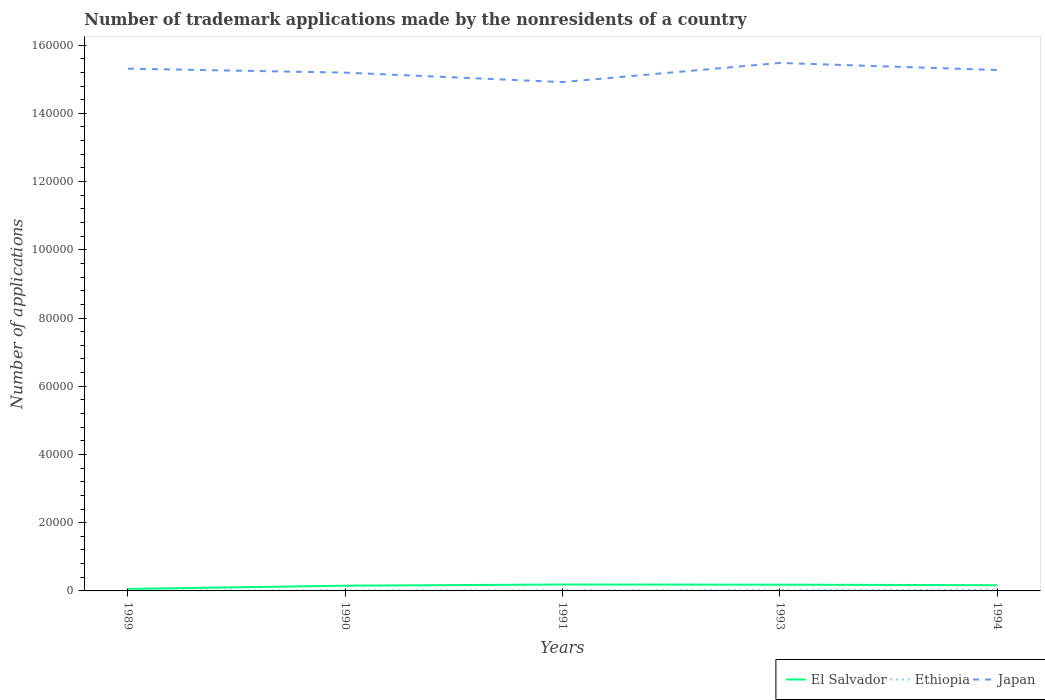How many different coloured lines are there?
Your response must be concise. 3. Across all years, what is the maximum number of trademark applications made by the nonresidents in Japan?
Make the answer very short. 1.49e+05. In which year was the number of trademark applications made by the nonresidents in Japan maximum?
Offer a very short reply. 1991. What is the total number of trademark applications made by the nonresidents in Japan in the graph?
Your answer should be very brief. -2839. What is the difference between the highest and the second highest number of trademark applications made by the nonresidents in Ethiopia?
Offer a terse response. 217. How many lines are there?
Provide a short and direct response. 3. Are the values on the major ticks of Y-axis written in scientific E-notation?
Offer a very short reply. No. How many legend labels are there?
Ensure brevity in your answer.  3. How are the legend labels stacked?
Provide a succinct answer. Horizontal. What is the title of the graph?
Ensure brevity in your answer.  Number of trademark applications made by the nonresidents of a country. What is the label or title of the Y-axis?
Give a very brief answer. Number of applications. What is the Number of applications of El Salvador in 1989?
Offer a very short reply. 581. What is the Number of applications in Ethiopia in 1989?
Provide a short and direct response. 128. What is the Number of applications of Japan in 1989?
Your answer should be very brief. 1.53e+05. What is the Number of applications in El Salvador in 1990?
Give a very brief answer. 1535. What is the Number of applications in Ethiopia in 1990?
Make the answer very short. 177. What is the Number of applications of Japan in 1990?
Ensure brevity in your answer.  1.52e+05. What is the Number of applications in El Salvador in 1991?
Provide a succinct answer. 1883. What is the Number of applications of Ethiopia in 1991?
Ensure brevity in your answer.  156. What is the Number of applications in Japan in 1991?
Keep it short and to the point. 1.49e+05. What is the Number of applications in El Salvador in 1993?
Make the answer very short. 1834. What is the Number of applications in Ethiopia in 1993?
Your answer should be compact. 235. What is the Number of applications in Japan in 1993?
Provide a succinct answer. 1.55e+05. What is the Number of applications in El Salvador in 1994?
Offer a very short reply. 1681. What is the Number of applications in Ethiopia in 1994?
Keep it short and to the point. 345. What is the Number of applications of Japan in 1994?
Offer a terse response. 1.53e+05. Across all years, what is the maximum Number of applications in El Salvador?
Ensure brevity in your answer.  1883. Across all years, what is the maximum Number of applications of Ethiopia?
Keep it short and to the point. 345. Across all years, what is the maximum Number of applications in Japan?
Make the answer very short. 1.55e+05. Across all years, what is the minimum Number of applications in El Salvador?
Your response must be concise. 581. Across all years, what is the minimum Number of applications in Ethiopia?
Keep it short and to the point. 128. Across all years, what is the minimum Number of applications in Japan?
Your answer should be very brief. 1.49e+05. What is the total Number of applications of El Salvador in the graph?
Your answer should be very brief. 7514. What is the total Number of applications in Ethiopia in the graph?
Offer a very short reply. 1041. What is the total Number of applications of Japan in the graph?
Your answer should be very brief. 7.62e+05. What is the difference between the Number of applications of El Salvador in 1989 and that in 1990?
Provide a short and direct response. -954. What is the difference between the Number of applications of Ethiopia in 1989 and that in 1990?
Your answer should be compact. -49. What is the difference between the Number of applications in Japan in 1989 and that in 1990?
Give a very brief answer. 1166. What is the difference between the Number of applications of El Salvador in 1989 and that in 1991?
Your answer should be very brief. -1302. What is the difference between the Number of applications of Japan in 1989 and that in 1991?
Your response must be concise. 3938. What is the difference between the Number of applications of El Salvador in 1989 and that in 1993?
Make the answer very short. -1253. What is the difference between the Number of applications in Ethiopia in 1989 and that in 1993?
Offer a very short reply. -107. What is the difference between the Number of applications in Japan in 1989 and that in 1993?
Give a very brief answer. -1673. What is the difference between the Number of applications in El Salvador in 1989 and that in 1994?
Your response must be concise. -1100. What is the difference between the Number of applications of Ethiopia in 1989 and that in 1994?
Ensure brevity in your answer.  -217. What is the difference between the Number of applications of Japan in 1989 and that in 1994?
Your response must be concise. 393. What is the difference between the Number of applications of El Salvador in 1990 and that in 1991?
Give a very brief answer. -348. What is the difference between the Number of applications in Ethiopia in 1990 and that in 1991?
Make the answer very short. 21. What is the difference between the Number of applications in Japan in 1990 and that in 1991?
Keep it short and to the point. 2772. What is the difference between the Number of applications of El Salvador in 1990 and that in 1993?
Provide a short and direct response. -299. What is the difference between the Number of applications in Ethiopia in 1990 and that in 1993?
Offer a very short reply. -58. What is the difference between the Number of applications of Japan in 1990 and that in 1993?
Offer a terse response. -2839. What is the difference between the Number of applications of El Salvador in 1990 and that in 1994?
Keep it short and to the point. -146. What is the difference between the Number of applications in Ethiopia in 1990 and that in 1994?
Provide a succinct answer. -168. What is the difference between the Number of applications of Japan in 1990 and that in 1994?
Your answer should be very brief. -773. What is the difference between the Number of applications of Ethiopia in 1991 and that in 1993?
Give a very brief answer. -79. What is the difference between the Number of applications of Japan in 1991 and that in 1993?
Your response must be concise. -5611. What is the difference between the Number of applications of El Salvador in 1991 and that in 1994?
Offer a terse response. 202. What is the difference between the Number of applications of Ethiopia in 1991 and that in 1994?
Provide a succinct answer. -189. What is the difference between the Number of applications in Japan in 1991 and that in 1994?
Ensure brevity in your answer.  -3545. What is the difference between the Number of applications in El Salvador in 1993 and that in 1994?
Offer a terse response. 153. What is the difference between the Number of applications of Ethiopia in 1993 and that in 1994?
Ensure brevity in your answer.  -110. What is the difference between the Number of applications of Japan in 1993 and that in 1994?
Provide a short and direct response. 2066. What is the difference between the Number of applications of El Salvador in 1989 and the Number of applications of Ethiopia in 1990?
Offer a very short reply. 404. What is the difference between the Number of applications in El Salvador in 1989 and the Number of applications in Japan in 1990?
Provide a short and direct response. -1.51e+05. What is the difference between the Number of applications in Ethiopia in 1989 and the Number of applications in Japan in 1990?
Give a very brief answer. -1.52e+05. What is the difference between the Number of applications of El Salvador in 1989 and the Number of applications of Ethiopia in 1991?
Make the answer very short. 425. What is the difference between the Number of applications of El Salvador in 1989 and the Number of applications of Japan in 1991?
Provide a succinct answer. -1.49e+05. What is the difference between the Number of applications in Ethiopia in 1989 and the Number of applications in Japan in 1991?
Offer a very short reply. -1.49e+05. What is the difference between the Number of applications in El Salvador in 1989 and the Number of applications in Ethiopia in 1993?
Your response must be concise. 346. What is the difference between the Number of applications in El Salvador in 1989 and the Number of applications in Japan in 1993?
Provide a short and direct response. -1.54e+05. What is the difference between the Number of applications of Ethiopia in 1989 and the Number of applications of Japan in 1993?
Your response must be concise. -1.55e+05. What is the difference between the Number of applications of El Salvador in 1989 and the Number of applications of Ethiopia in 1994?
Your answer should be very brief. 236. What is the difference between the Number of applications in El Salvador in 1989 and the Number of applications in Japan in 1994?
Make the answer very short. -1.52e+05. What is the difference between the Number of applications in Ethiopia in 1989 and the Number of applications in Japan in 1994?
Your answer should be very brief. -1.53e+05. What is the difference between the Number of applications of El Salvador in 1990 and the Number of applications of Ethiopia in 1991?
Give a very brief answer. 1379. What is the difference between the Number of applications of El Salvador in 1990 and the Number of applications of Japan in 1991?
Make the answer very short. -1.48e+05. What is the difference between the Number of applications of Ethiopia in 1990 and the Number of applications of Japan in 1991?
Provide a succinct answer. -1.49e+05. What is the difference between the Number of applications of El Salvador in 1990 and the Number of applications of Ethiopia in 1993?
Your answer should be very brief. 1300. What is the difference between the Number of applications of El Salvador in 1990 and the Number of applications of Japan in 1993?
Provide a succinct answer. -1.53e+05. What is the difference between the Number of applications in Ethiopia in 1990 and the Number of applications in Japan in 1993?
Offer a terse response. -1.55e+05. What is the difference between the Number of applications of El Salvador in 1990 and the Number of applications of Ethiopia in 1994?
Offer a terse response. 1190. What is the difference between the Number of applications of El Salvador in 1990 and the Number of applications of Japan in 1994?
Provide a short and direct response. -1.51e+05. What is the difference between the Number of applications in Ethiopia in 1990 and the Number of applications in Japan in 1994?
Your answer should be compact. -1.53e+05. What is the difference between the Number of applications of El Salvador in 1991 and the Number of applications of Ethiopia in 1993?
Your response must be concise. 1648. What is the difference between the Number of applications of El Salvador in 1991 and the Number of applications of Japan in 1993?
Offer a terse response. -1.53e+05. What is the difference between the Number of applications of Ethiopia in 1991 and the Number of applications of Japan in 1993?
Your response must be concise. -1.55e+05. What is the difference between the Number of applications of El Salvador in 1991 and the Number of applications of Ethiopia in 1994?
Your response must be concise. 1538. What is the difference between the Number of applications in El Salvador in 1991 and the Number of applications in Japan in 1994?
Give a very brief answer. -1.51e+05. What is the difference between the Number of applications in Ethiopia in 1991 and the Number of applications in Japan in 1994?
Ensure brevity in your answer.  -1.53e+05. What is the difference between the Number of applications of El Salvador in 1993 and the Number of applications of Ethiopia in 1994?
Keep it short and to the point. 1489. What is the difference between the Number of applications in El Salvador in 1993 and the Number of applications in Japan in 1994?
Offer a terse response. -1.51e+05. What is the difference between the Number of applications of Ethiopia in 1993 and the Number of applications of Japan in 1994?
Your response must be concise. -1.52e+05. What is the average Number of applications in El Salvador per year?
Provide a short and direct response. 1502.8. What is the average Number of applications of Ethiopia per year?
Make the answer very short. 208.2. What is the average Number of applications in Japan per year?
Your answer should be very brief. 1.52e+05. In the year 1989, what is the difference between the Number of applications of El Salvador and Number of applications of Ethiopia?
Ensure brevity in your answer.  453. In the year 1989, what is the difference between the Number of applications in El Salvador and Number of applications in Japan?
Provide a succinct answer. -1.53e+05. In the year 1989, what is the difference between the Number of applications in Ethiopia and Number of applications in Japan?
Offer a terse response. -1.53e+05. In the year 1990, what is the difference between the Number of applications of El Salvador and Number of applications of Ethiopia?
Your response must be concise. 1358. In the year 1990, what is the difference between the Number of applications of El Salvador and Number of applications of Japan?
Keep it short and to the point. -1.50e+05. In the year 1990, what is the difference between the Number of applications of Ethiopia and Number of applications of Japan?
Offer a very short reply. -1.52e+05. In the year 1991, what is the difference between the Number of applications in El Salvador and Number of applications in Ethiopia?
Provide a succinct answer. 1727. In the year 1991, what is the difference between the Number of applications of El Salvador and Number of applications of Japan?
Provide a short and direct response. -1.47e+05. In the year 1991, what is the difference between the Number of applications of Ethiopia and Number of applications of Japan?
Your response must be concise. -1.49e+05. In the year 1993, what is the difference between the Number of applications of El Salvador and Number of applications of Ethiopia?
Offer a very short reply. 1599. In the year 1993, what is the difference between the Number of applications of El Salvador and Number of applications of Japan?
Give a very brief answer. -1.53e+05. In the year 1993, what is the difference between the Number of applications of Ethiopia and Number of applications of Japan?
Offer a very short reply. -1.55e+05. In the year 1994, what is the difference between the Number of applications of El Salvador and Number of applications of Ethiopia?
Your answer should be very brief. 1336. In the year 1994, what is the difference between the Number of applications of El Salvador and Number of applications of Japan?
Give a very brief answer. -1.51e+05. In the year 1994, what is the difference between the Number of applications in Ethiopia and Number of applications in Japan?
Your answer should be very brief. -1.52e+05. What is the ratio of the Number of applications of El Salvador in 1989 to that in 1990?
Offer a terse response. 0.38. What is the ratio of the Number of applications in Ethiopia in 1989 to that in 1990?
Offer a terse response. 0.72. What is the ratio of the Number of applications in Japan in 1989 to that in 1990?
Your answer should be compact. 1.01. What is the ratio of the Number of applications of El Salvador in 1989 to that in 1991?
Keep it short and to the point. 0.31. What is the ratio of the Number of applications of Ethiopia in 1989 to that in 1991?
Provide a short and direct response. 0.82. What is the ratio of the Number of applications in Japan in 1989 to that in 1991?
Provide a succinct answer. 1.03. What is the ratio of the Number of applications of El Salvador in 1989 to that in 1993?
Your answer should be compact. 0.32. What is the ratio of the Number of applications of Ethiopia in 1989 to that in 1993?
Your response must be concise. 0.54. What is the ratio of the Number of applications of Japan in 1989 to that in 1993?
Offer a terse response. 0.99. What is the ratio of the Number of applications in El Salvador in 1989 to that in 1994?
Ensure brevity in your answer.  0.35. What is the ratio of the Number of applications in Ethiopia in 1989 to that in 1994?
Give a very brief answer. 0.37. What is the ratio of the Number of applications of El Salvador in 1990 to that in 1991?
Give a very brief answer. 0.82. What is the ratio of the Number of applications of Ethiopia in 1990 to that in 1991?
Your answer should be compact. 1.13. What is the ratio of the Number of applications in Japan in 1990 to that in 1991?
Ensure brevity in your answer.  1.02. What is the ratio of the Number of applications of El Salvador in 1990 to that in 1993?
Provide a succinct answer. 0.84. What is the ratio of the Number of applications in Ethiopia in 1990 to that in 1993?
Your answer should be compact. 0.75. What is the ratio of the Number of applications of Japan in 1990 to that in 1993?
Make the answer very short. 0.98. What is the ratio of the Number of applications of El Salvador in 1990 to that in 1994?
Keep it short and to the point. 0.91. What is the ratio of the Number of applications in Ethiopia in 1990 to that in 1994?
Give a very brief answer. 0.51. What is the ratio of the Number of applications of El Salvador in 1991 to that in 1993?
Your answer should be compact. 1.03. What is the ratio of the Number of applications of Ethiopia in 1991 to that in 1993?
Give a very brief answer. 0.66. What is the ratio of the Number of applications of Japan in 1991 to that in 1993?
Your response must be concise. 0.96. What is the ratio of the Number of applications in El Salvador in 1991 to that in 1994?
Your response must be concise. 1.12. What is the ratio of the Number of applications in Ethiopia in 1991 to that in 1994?
Offer a very short reply. 0.45. What is the ratio of the Number of applications in Japan in 1991 to that in 1994?
Offer a very short reply. 0.98. What is the ratio of the Number of applications in El Salvador in 1993 to that in 1994?
Your response must be concise. 1.09. What is the ratio of the Number of applications in Ethiopia in 1993 to that in 1994?
Your answer should be compact. 0.68. What is the ratio of the Number of applications in Japan in 1993 to that in 1994?
Your response must be concise. 1.01. What is the difference between the highest and the second highest Number of applications of El Salvador?
Provide a succinct answer. 49. What is the difference between the highest and the second highest Number of applications of Ethiopia?
Your answer should be compact. 110. What is the difference between the highest and the second highest Number of applications of Japan?
Offer a terse response. 1673. What is the difference between the highest and the lowest Number of applications in El Salvador?
Keep it short and to the point. 1302. What is the difference between the highest and the lowest Number of applications of Ethiopia?
Provide a succinct answer. 217. What is the difference between the highest and the lowest Number of applications in Japan?
Offer a terse response. 5611. 